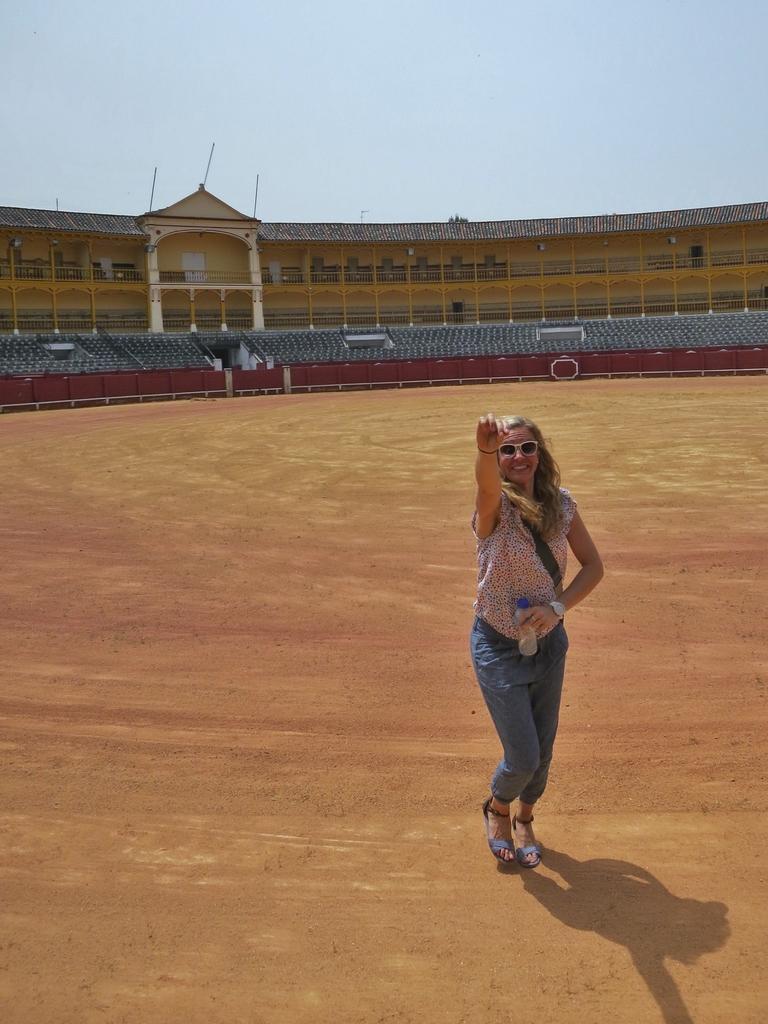Describe this image in one or two sentences. In this image, we can see a woman standing in the stadium, we can see some chairs and at the top we can see the sky. 